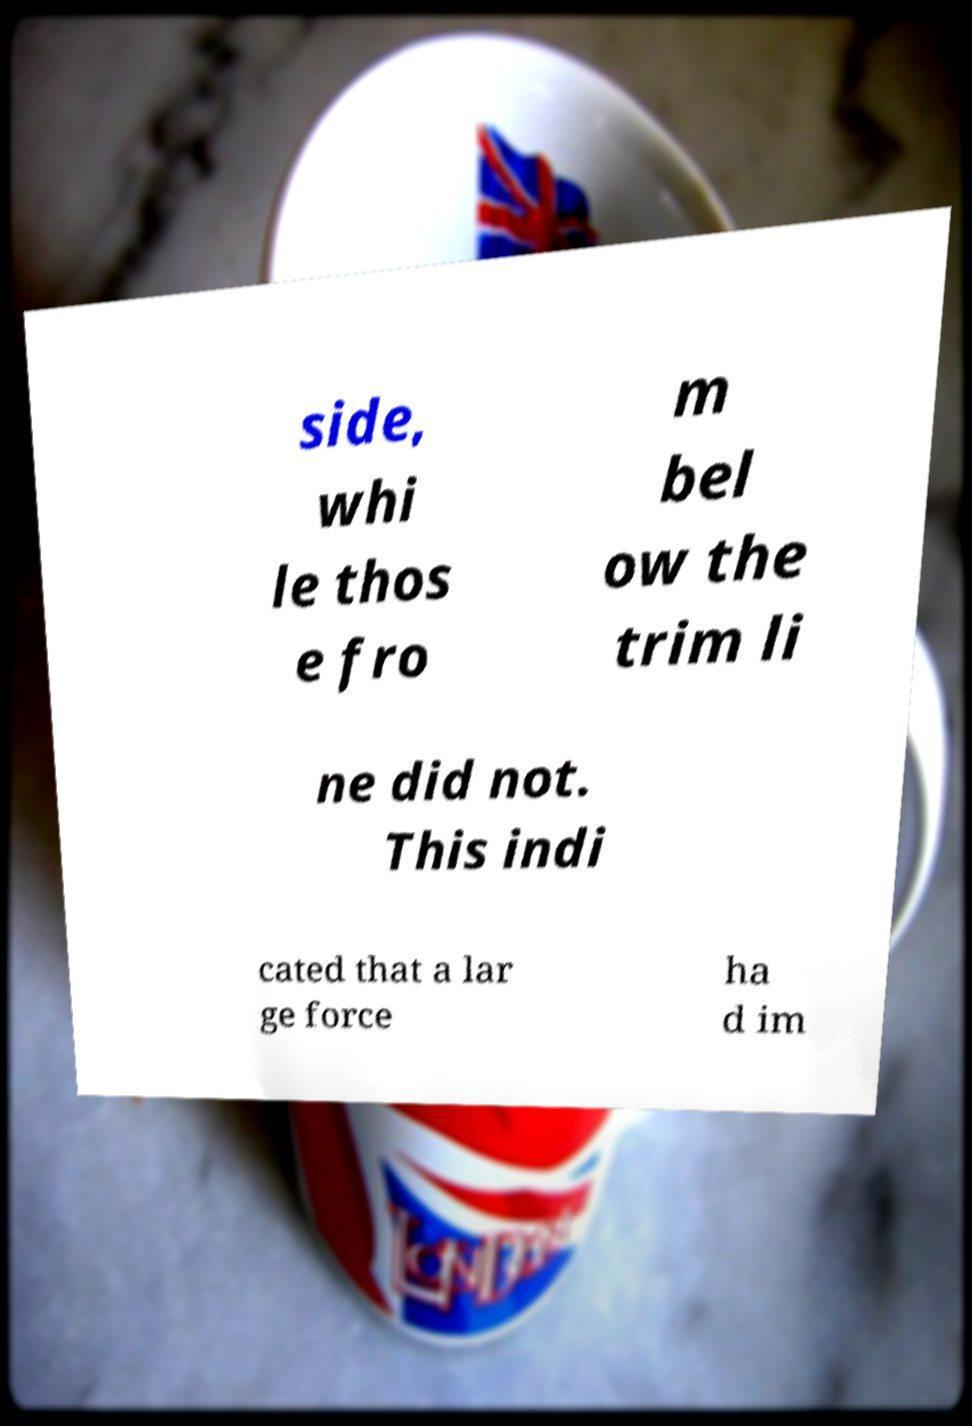Can you read and provide the text displayed in the image?This photo seems to have some interesting text. Can you extract and type it out for me? side, whi le thos e fro m bel ow the trim li ne did not. This indi cated that a lar ge force ha d im 